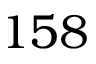Convert formula to latex. <formula><loc_0><loc_0><loc_500><loc_500>1 5 8</formula> 